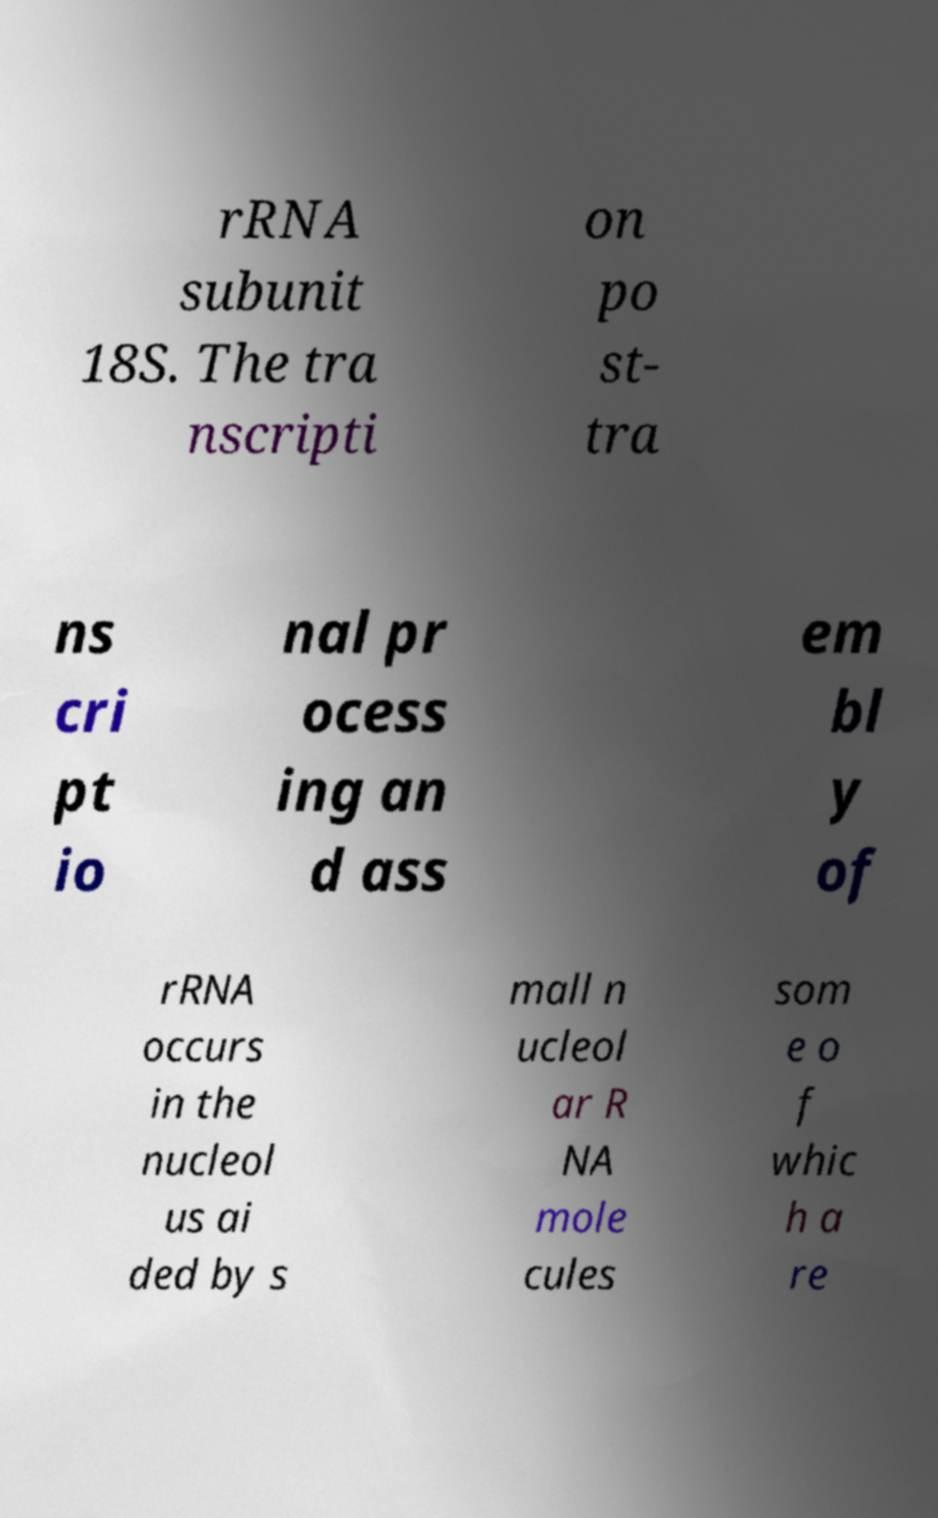Could you extract and type out the text from this image? rRNA subunit 18S. The tra nscripti on po st- tra ns cri pt io nal pr ocess ing an d ass em bl y of rRNA occurs in the nucleol us ai ded by s mall n ucleol ar R NA mole cules som e o f whic h a re 